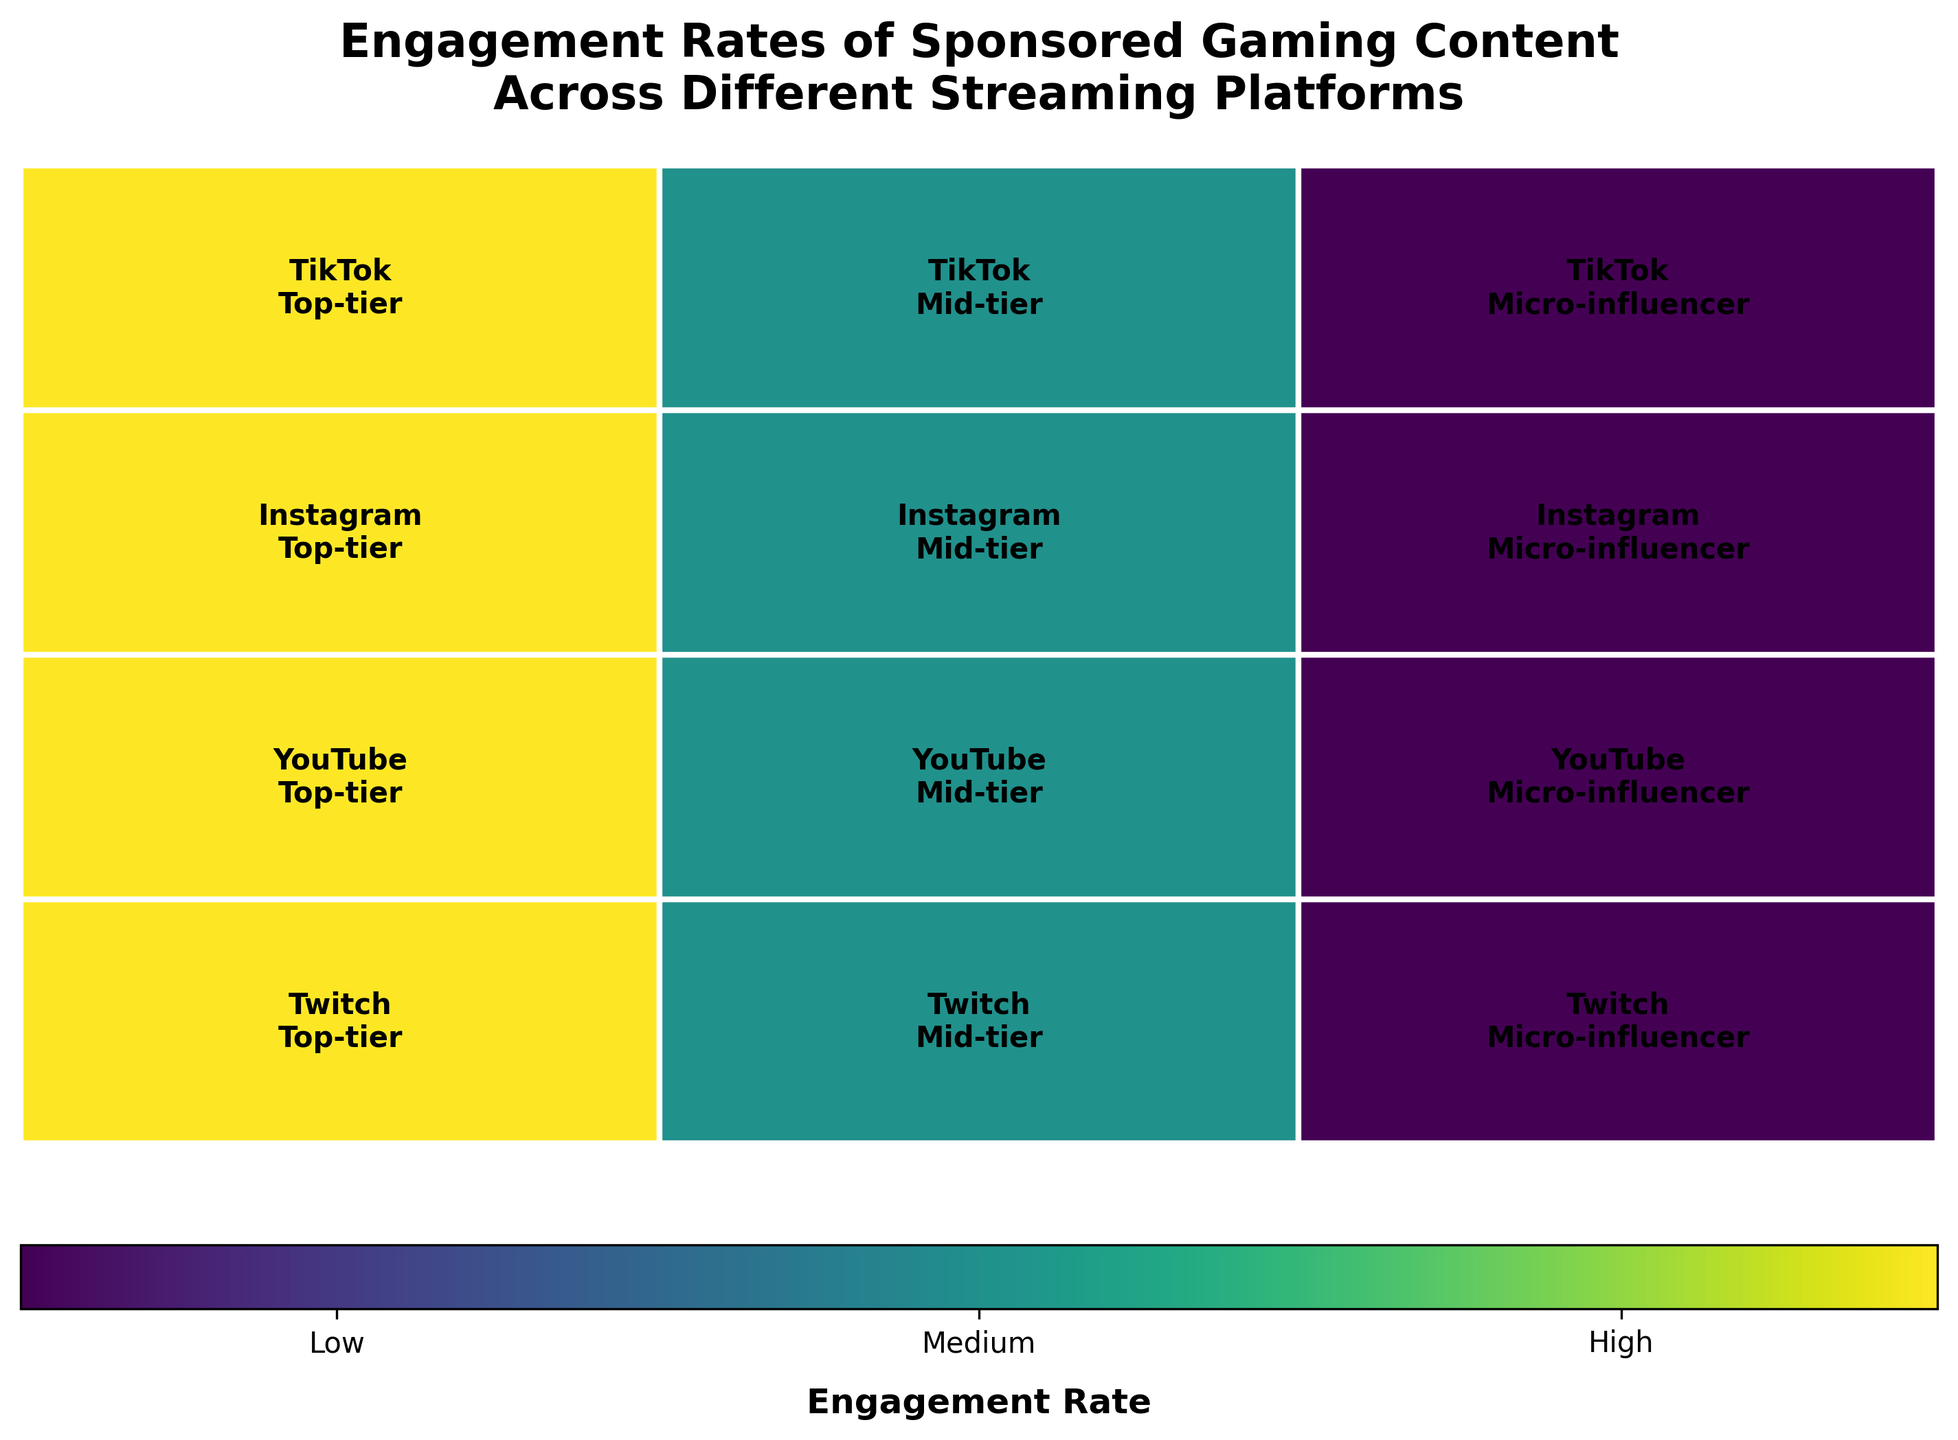What are the platforms shown in the plot? The plot includes four platforms as represented on the y-axis. Each rectangle in the row corresponds to a different platform.
Answer: Twitch, YouTube, Instagram, TikTok Which influencer tier has the highest engagement across all platforms? Each rectangle with darker shading indicates higher engagement. Top-tier influencers have the darker shades in each platform.
Answer: Top-tier How many engagement rate categories are used in the plot? The color bar at the bottom of the plot indicates different engagement rates marked as Low, Medium, and High, corresponding to three categories.
Answer: 3 What platform shows the highest engagement rate for Mid-tier influencers? Look for the platform that has the darkest shading for Mid-tier influencer tier. The one with the darkest color among the Mid-tier categories will be the answer.
Answer: Instagram Compare the engagement rates of Micro-influencer tier between TikTok and YouTube. By comparing the color shade in the Micro-influencer sections of both platforms, we see TikTok has a lighter color compared to YouTube, meaning TikTok has lower engagement for Micro-influencers.
Answer: YouTube Which platform shows medium engagement rate for Live Stream content type? By locating the Live Stream content type in the Twitch platform and finding the medium shade, we can identify the engagement rate.
Answer: Twitch What content type has the highest engagement rate for Top-tier influencers? Observe the pattern across all platforms and find the content type where the Top-tier influencers consistently exhibit the darkest shades.
Answer: Live Stream How does the engagement rate for Top-tier influencers on TikTok compare to Instagram? By comparing the shades in the Top-tier influencer sections of both TikTok and Instagram, we can conclude that TikTok has darker shading than Instagram, indicating a higher engagement rate.
Answer: TikTok What is the engagement rate for Mid-tier influencers on YouTube? Checking the color for YouTube's Mid-tier influencer section, it matches the medium shade on the color scale.
Answer: Medium If a new platform is to be chosen for a campaign targeting Mid-tier influencers, which one could be the best option according to the plot? Evaluate the shades for Mid-tier influencers across all platforms, and Instagram shows the darkest shade indicating the highest engagement.
Answer: Instagram 